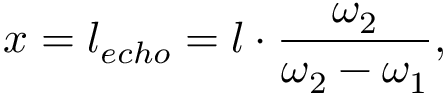Convert formula to latex. <formula><loc_0><loc_0><loc_500><loc_500>x = l _ { e c h o } = l \cdot \frac { \omega _ { 2 } } { \omega _ { 2 } - \omega _ { 1 } } ,</formula> 